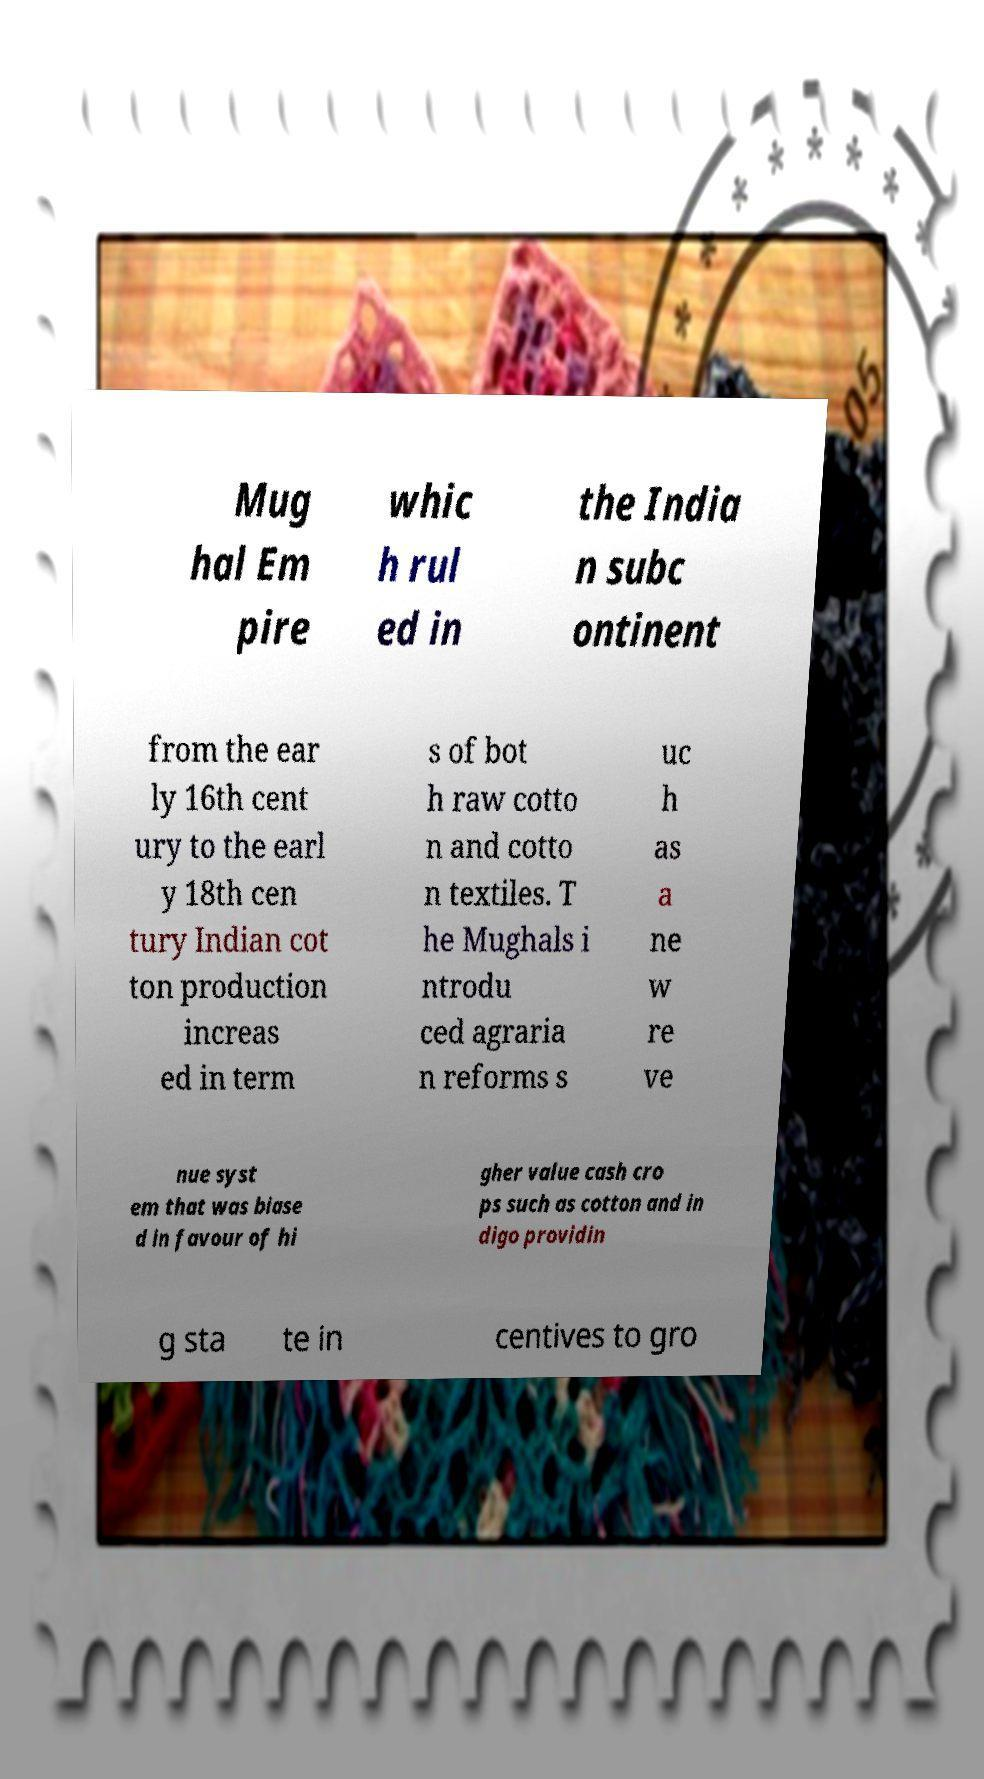Please identify and transcribe the text found in this image. Mug hal Em pire whic h rul ed in the India n subc ontinent from the ear ly 16th cent ury to the earl y 18th cen tury Indian cot ton production increas ed in term s of bot h raw cotto n and cotto n textiles. T he Mughals i ntrodu ced agraria n reforms s uc h as a ne w re ve nue syst em that was biase d in favour of hi gher value cash cro ps such as cotton and in digo providin g sta te in centives to gro 